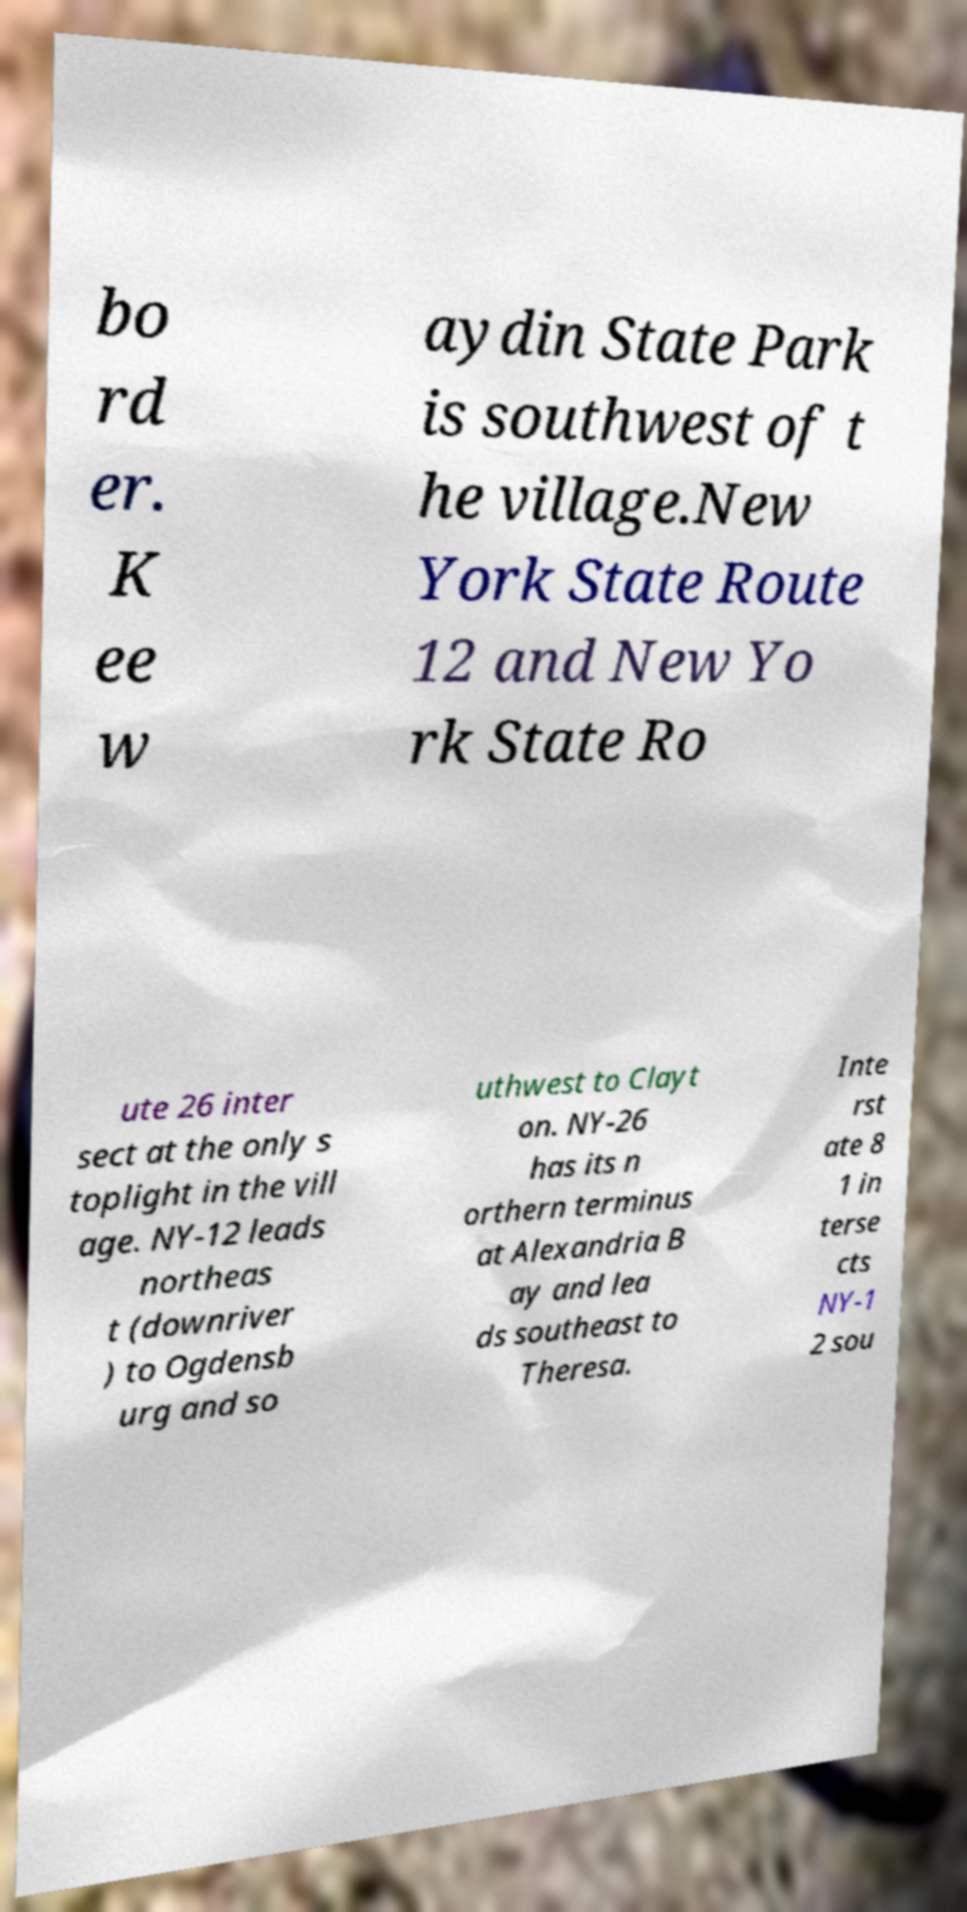Please identify and transcribe the text found in this image. bo rd er. K ee w aydin State Park is southwest of t he village.New York State Route 12 and New Yo rk State Ro ute 26 inter sect at the only s toplight in the vill age. NY-12 leads northeas t (downriver ) to Ogdensb urg and so uthwest to Clayt on. NY-26 has its n orthern terminus at Alexandria B ay and lea ds southeast to Theresa. Inte rst ate 8 1 in terse cts NY-1 2 sou 